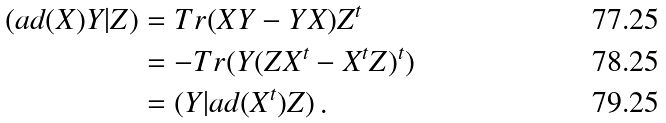<formula> <loc_0><loc_0><loc_500><loc_500>( a d ( X ) Y | Z ) & = T r ( X Y - Y X ) Z ^ { t } \\ & = - T r ( Y ( Z X ^ { t } - X ^ { t } Z ) ^ { t } ) \\ & = ( Y | a d ( X ^ { t } ) Z ) \, .</formula> 